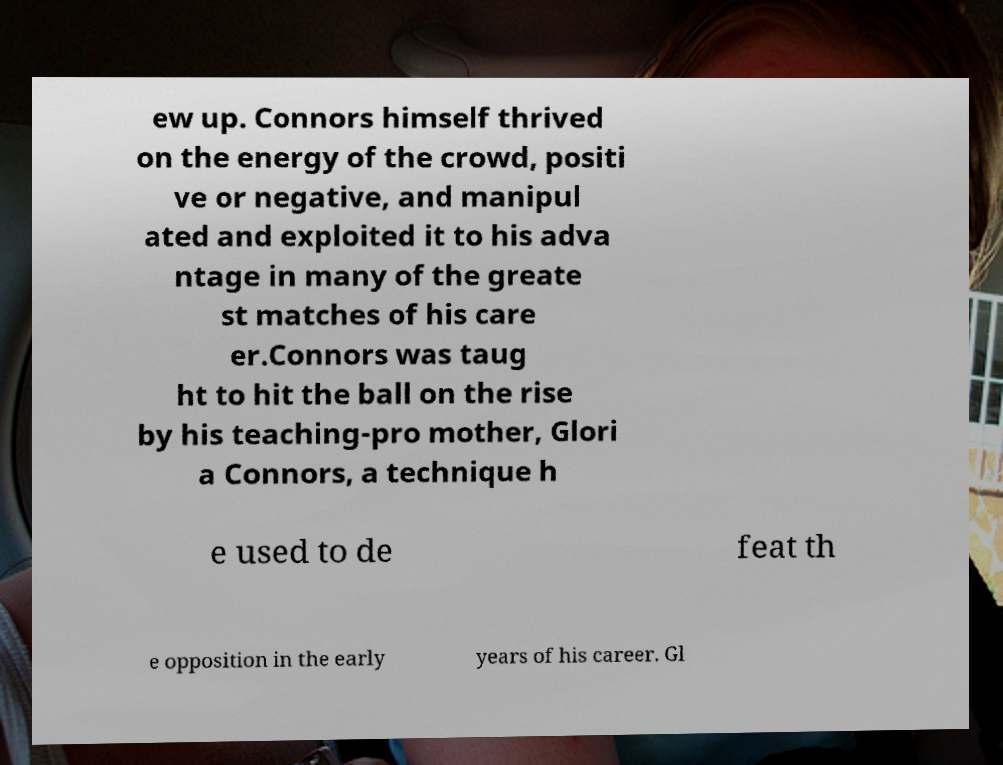For documentation purposes, I need the text within this image transcribed. Could you provide that? ew up. Connors himself thrived on the energy of the crowd, positi ve or negative, and manipul ated and exploited it to his adva ntage in many of the greate st matches of his care er.Connors was taug ht to hit the ball on the rise by his teaching-pro mother, Glori a Connors, a technique h e used to de feat th e opposition in the early years of his career. Gl 